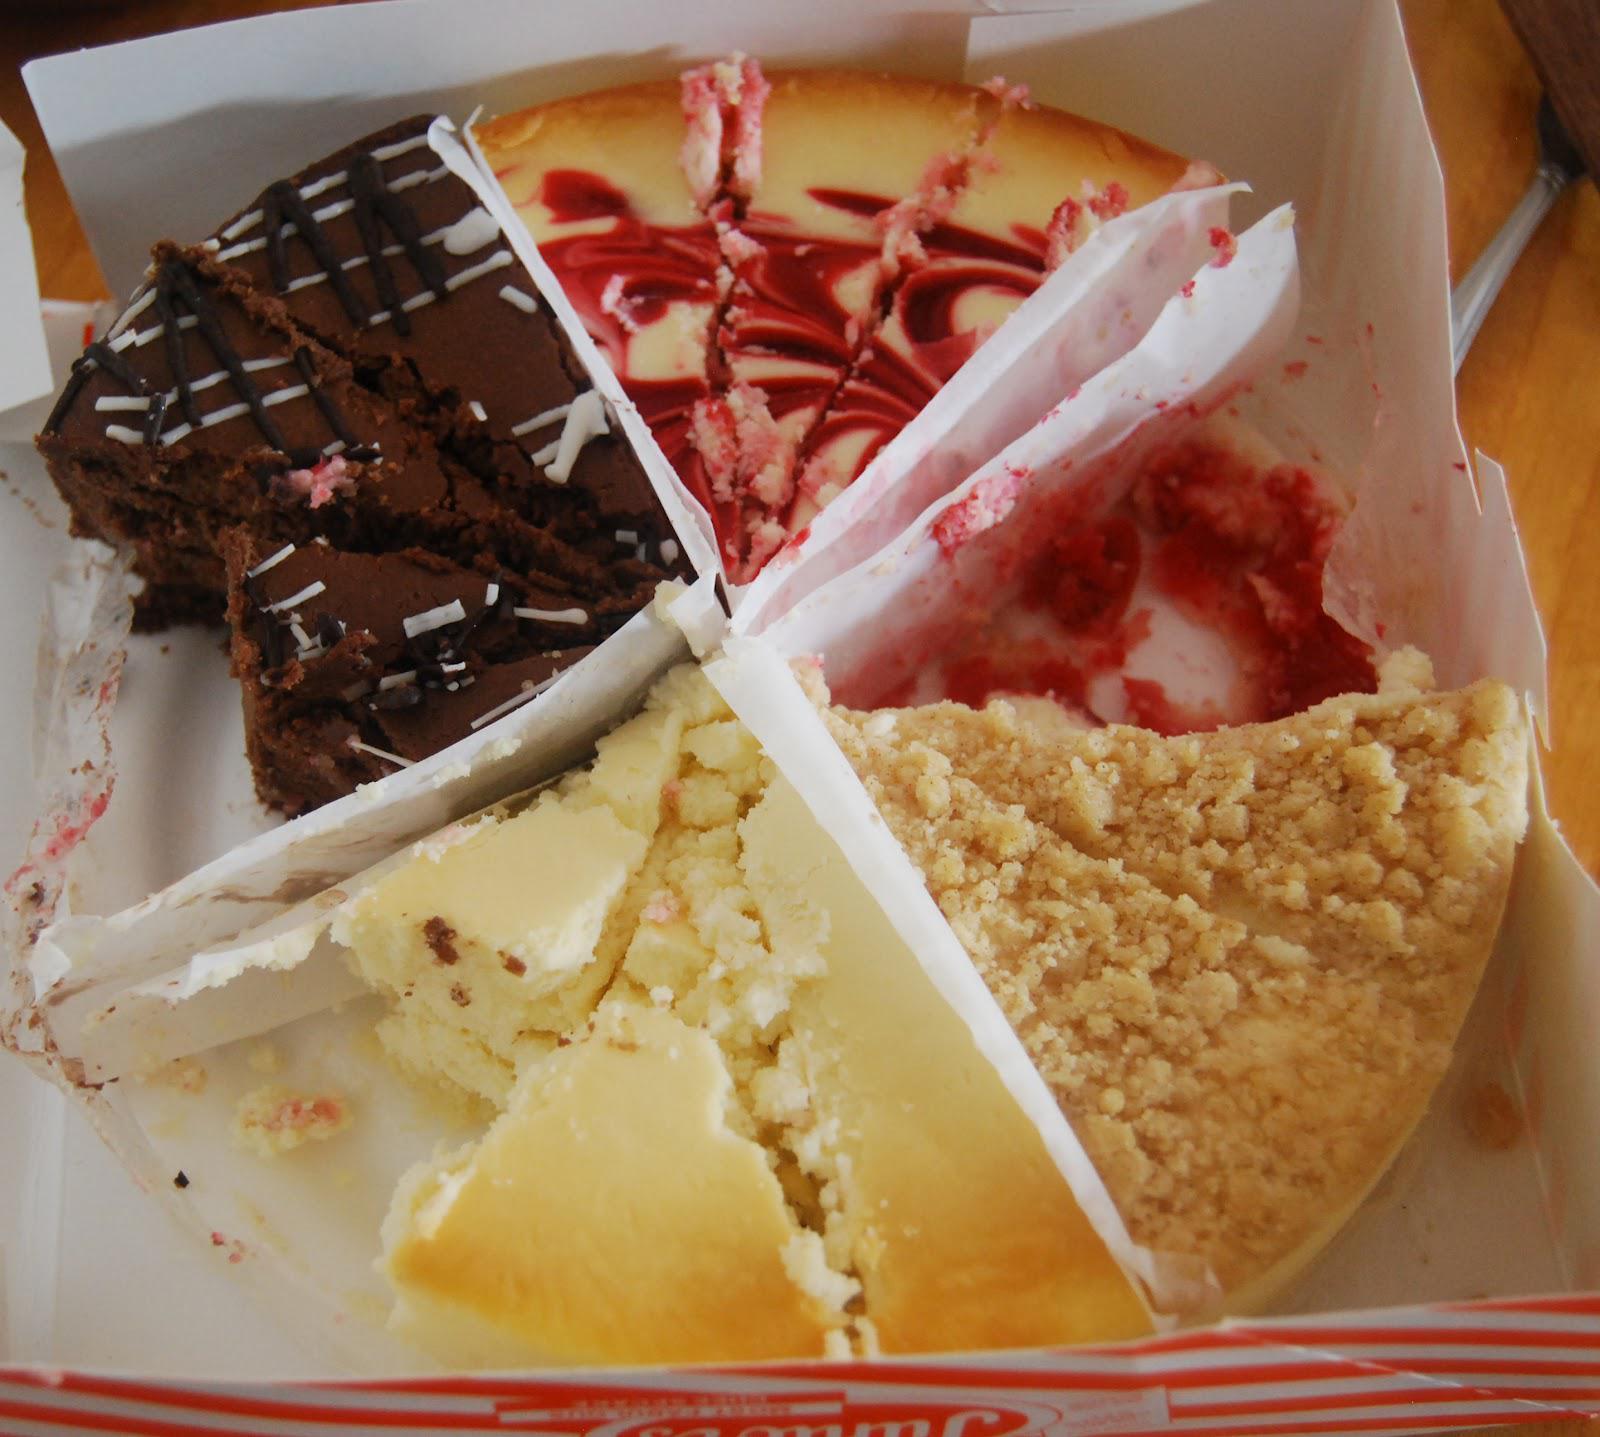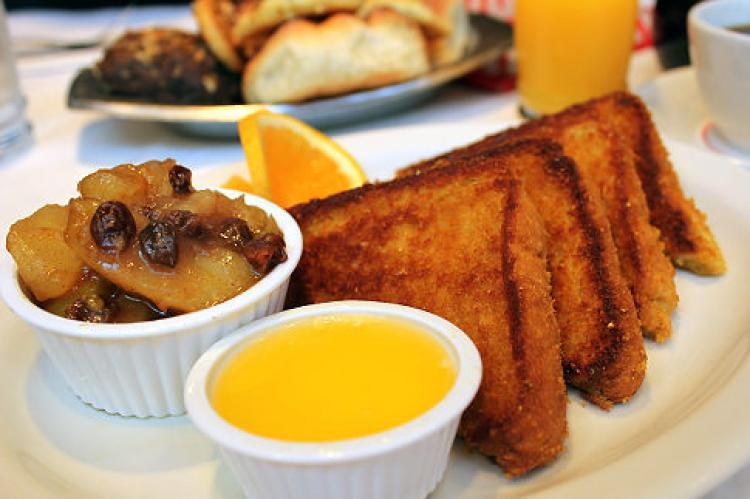The first image is the image on the left, the second image is the image on the right. For the images shown, is this caption "There is a human hand reaching for a dessert." true? Answer yes or no. No. 